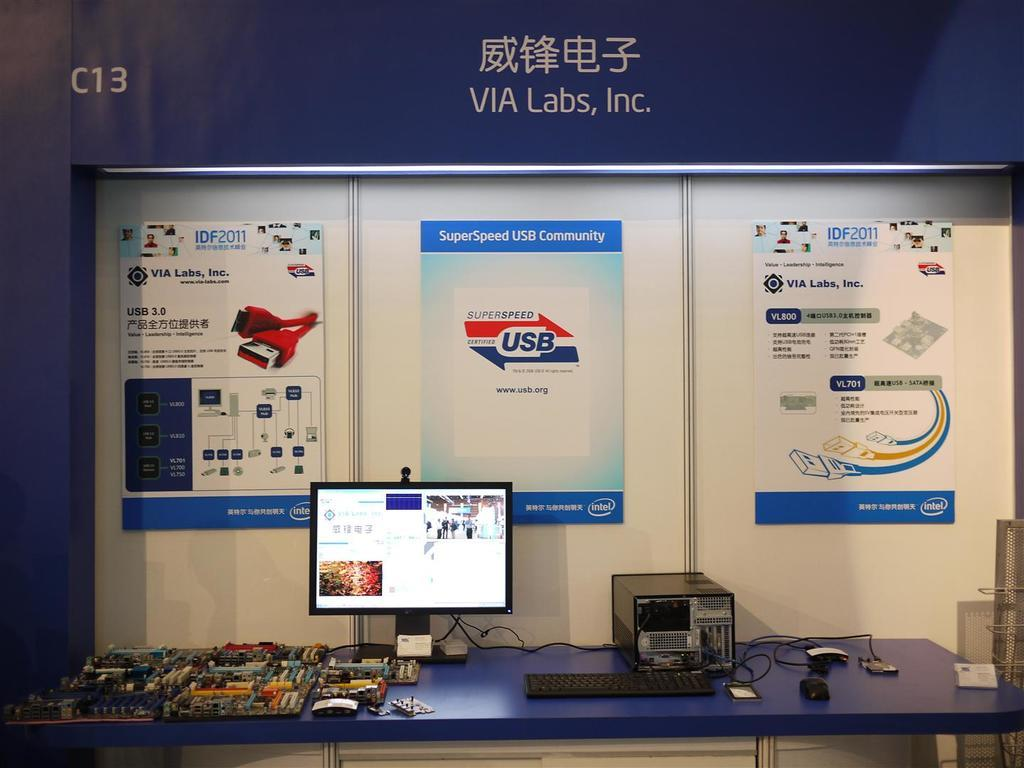<image>
Relay a brief, clear account of the picture shown. Computer system that is inside the lab building 